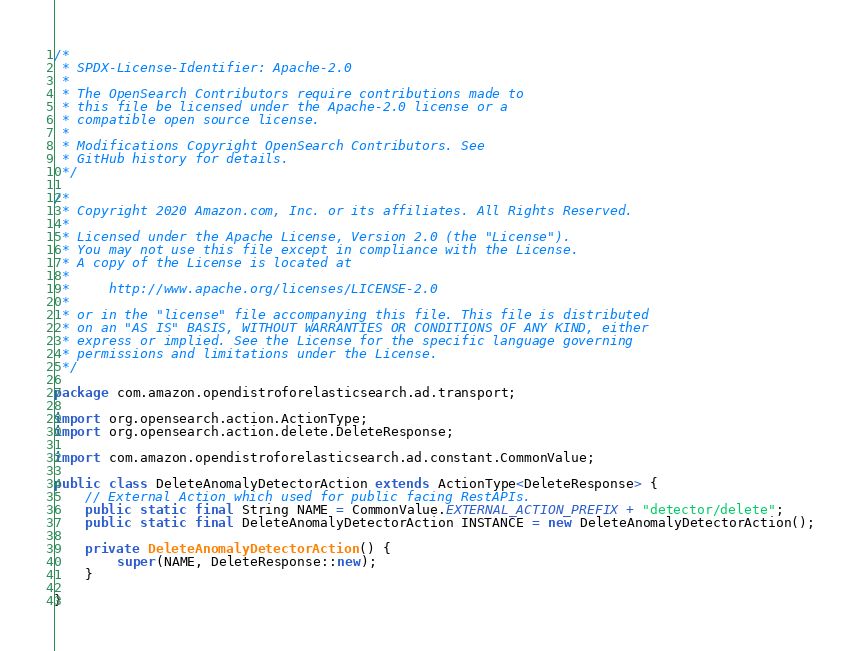<code> <loc_0><loc_0><loc_500><loc_500><_Java_>/*
 * SPDX-License-Identifier: Apache-2.0
 *
 * The OpenSearch Contributors require contributions made to
 * this file be licensed under the Apache-2.0 license or a
 * compatible open source license.
 *
 * Modifications Copyright OpenSearch Contributors. See
 * GitHub history for details.
 */

/*
 * Copyright 2020 Amazon.com, Inc. or its affiliates. All Rights Reserved.
 *
 * Licensed under the Apache License, Version 2.0 (the "License").
 * You may not use this file except in compliance with the License.
 * A copy of the License is located at
 *
 *     http://www.apache.org/licenses/LICENSE-2.0
 *
 * or in the "license" file accompanying this file. This file is distributed
 * on an "AS IS" BASIS, WITHOUT WARRANTIES OR CONDITIONS OF ANY KIND, either
 * express or implied. See the License for the specific language governing
 * permissions and limitations under the License.
 */

package com.amazon.opendistroforelasticsearch.ad.transport;

import org.opensearch.action.ActionType;
import org.opensearch.action.delete.DeleteResponse;

import com.amazon.opendistroforelasticsearch.ad.constant.CommonValue;

public class DeleteAnomalyDetectorAction extends ActionType<DeleteResponse> {
    // External Action which used for public facing RestAPIs.
    public static final String NAME = CommonValue.EXTERNAL_ACTION_PREFIX + "detector/delete";
    public static final DeleteAnomalyDetectorAction INSTANCE = new DeleteAnomalyDetectorAction();

    private DeleteAnomalyDetectorAction() {
        super(NAME, DeleteResponse::new);
    }

}
</code> 